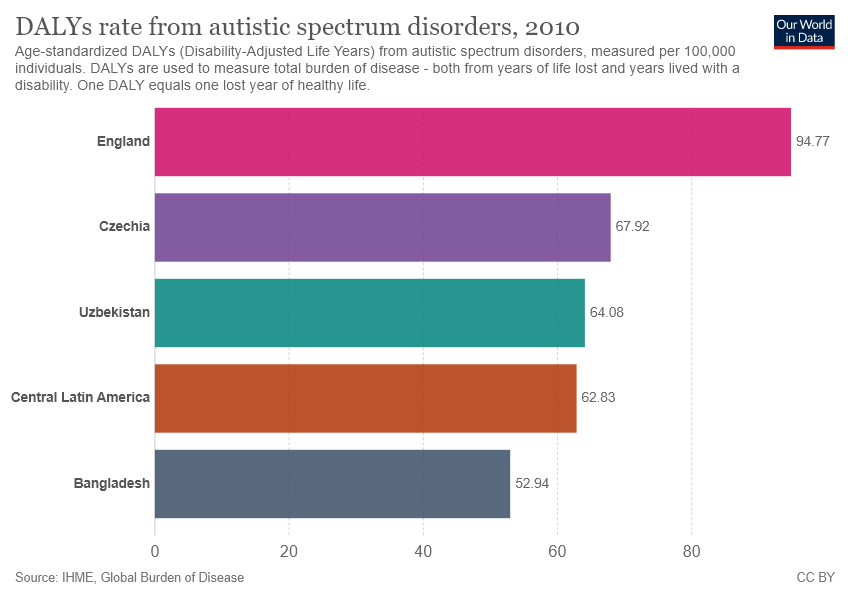Give some essential details in this illustration. In 2010, the rate of Disability-Adjusted Life Years (DALYs) due to autistic spectrum disorders in England was 94.77. In 2010, a total of four countries had DALY rates from autistic spectrum disorders that were over 60. 